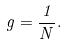Convert formula to latex. <formula><loc_0><loc_0><loc_500><loc_500>g = \frac { 1 } { N } .</formula> 